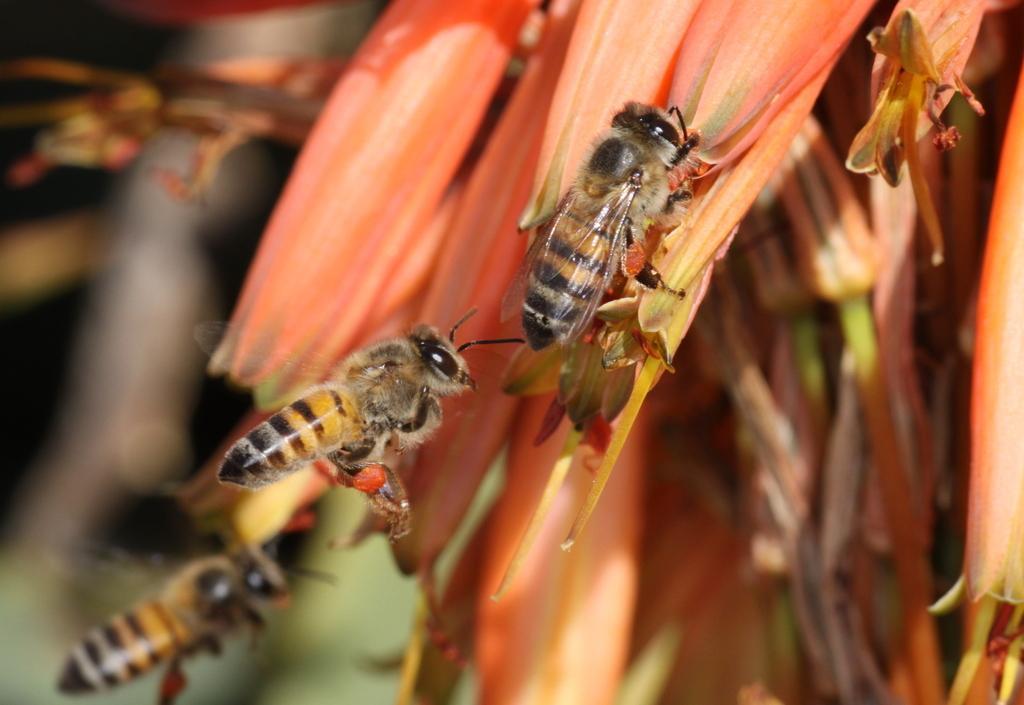How would you summarize this image in a sentence or two? There is a bee on a flower. Beside this bee, there is another bee which is in the air. In the background, there is another bee and there are flowers. And the background is blurred. 